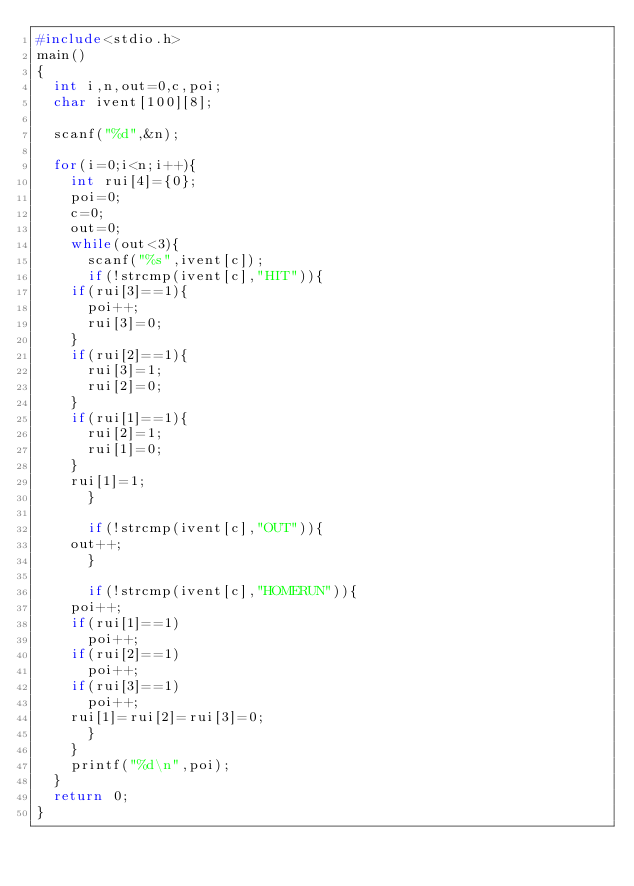<code> <loc_0><loc_0><loc_500><loc_500><_C_>#include<stdio.h>
main()
{
  int i,n,out=0,c,poi;
  char ivent[100][8];

  scanf("%d",&n);

  for(i=0;i<n;i++){
    int rui[4]={0};
    poi=0;
    c=0;
    out=0;
    while(out<3){
      scanf("%s",ivent[c]);
      if(!strcmp(ivent[c],"HIT")){
	if(rui[3]==1){
	  poi++;
	  rui[3]=0;
	}
	if(rui[2]==1){
	  rui[3]=1;
	  rui[2]=0;
	}
	if(rui[1]==1){
	  rui[2]=1;
	  rui[1]=0;
	}
	rui[1]=1;
      }

      if(!strcmp(ivent[c],"OUT")){
	out++;
      }

      if(!strcmp(ivent[c],"HOMERUN")){
	poi++;
	if(rui[1]==1)
	  poi++;
	if(rui[2]==1)
	  poi++;
	if(rui[3]==1)
	  poi++;
	rui[1]=rui[2]=rui[3]=0;
      }
    }
    printf("%d\n",poi);
  }
  return 0;
}</code> 